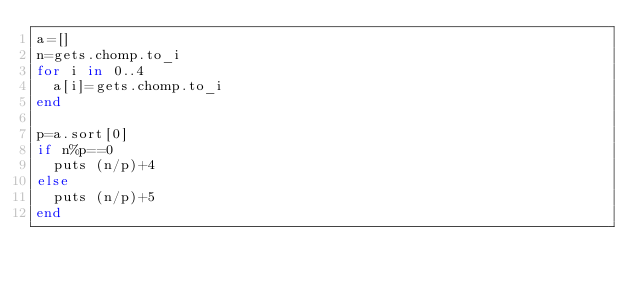Convert code to text. <code><loc_0><loc_0><loc_500><loc_500><_Ruby_>a=[]
n=gets.chomp.to_i
for i in 0..4
  a[i]=gets.chomp.to_i
end

p=a.sort[0]
if n%p==0
  puts (n/p)+4
else
  puts (n/p)+5
end</code> 